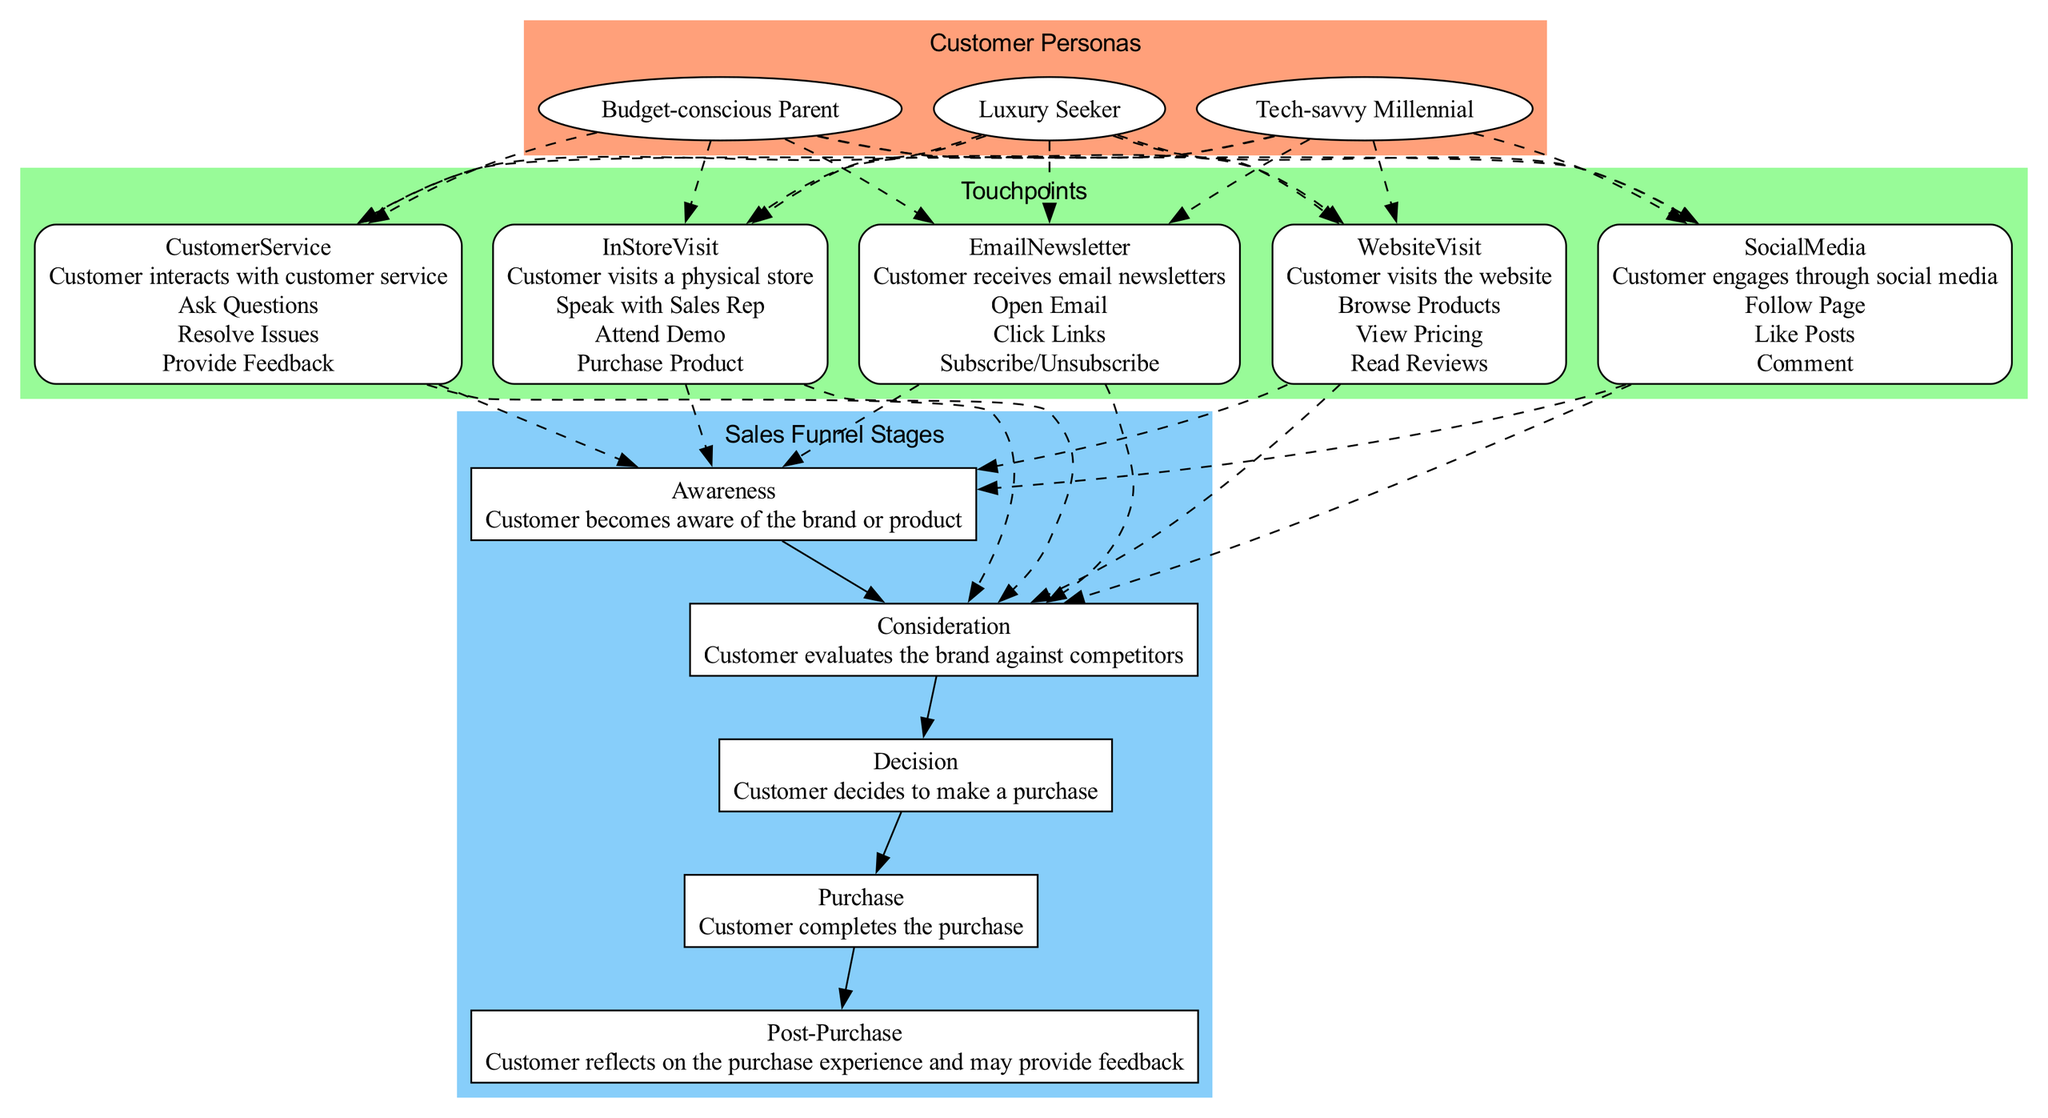What are the three customer personas depicted in the diagram? The customer personas are listed in the "Customer Personas" section of the diagram. They include "Tech-savvy Millennial," "Budget-conscious Parent," and "Luxury Seeker."
Answer: Tech-savvy Millennial, Budget-conscious Parent, Luxury Seeker How many touchpoints are shown in the diagram? The diagram lists five specific touchpoints: Website Visit, Social Media, Customer Service, In-Store Visit, and Email Newsletter. Counting these gives us a total of five touchpoints.
Answer: 5 What touches the "Post-Purchase" stage in the sales funnel? The touchpoints connect to multiple stages, but in particular, the "Customer Service" touchpoint connects to the "Post-Purchase" stage, indicating that customer service is crucial in this phase.
Answer: Customer Service Which persona might primarily interact with social media? Given the personas, "Tech-savvy Millennial" is likely to engage with social media more than the others, as they are characterized by being proficient with technology and social platforms.
Answer: Tech-savvy Millennial How many actions are associated with the "In-Store Visit" touchpoint? The "In-Store Visit" touchpoint lists three actions: Speak with Sales Rep, Attend Demo, and Purchase Product. Therefore, there are three actions that associate with it.
Answer: 3 Which sales funnel stage comes directly after "Consideration"? Within the Sales Funnel Stages, "Decision" is the stage that directly follows "Consideration." This indicates the customer's transition from evaluating options to deciding on a purchase.
Answer: Decision What describes the "Email Newsletter" touchpoint? The "Email Newsletter" touchpoint description from the diagram states that it involves receiving email newsletters, where actions include Open Email, Click Links, and Subscribe/Unsubscribe.
Answer: Receiving email newsletters Which customer persona is likely to provide feedback after a purchase? The "Budget-conscious Parent" is often more inclined to reflect on their spending and may provide feedback after evaluating the purchase experience, especially if looking for value.
Answer: Budget-conscious Parent 